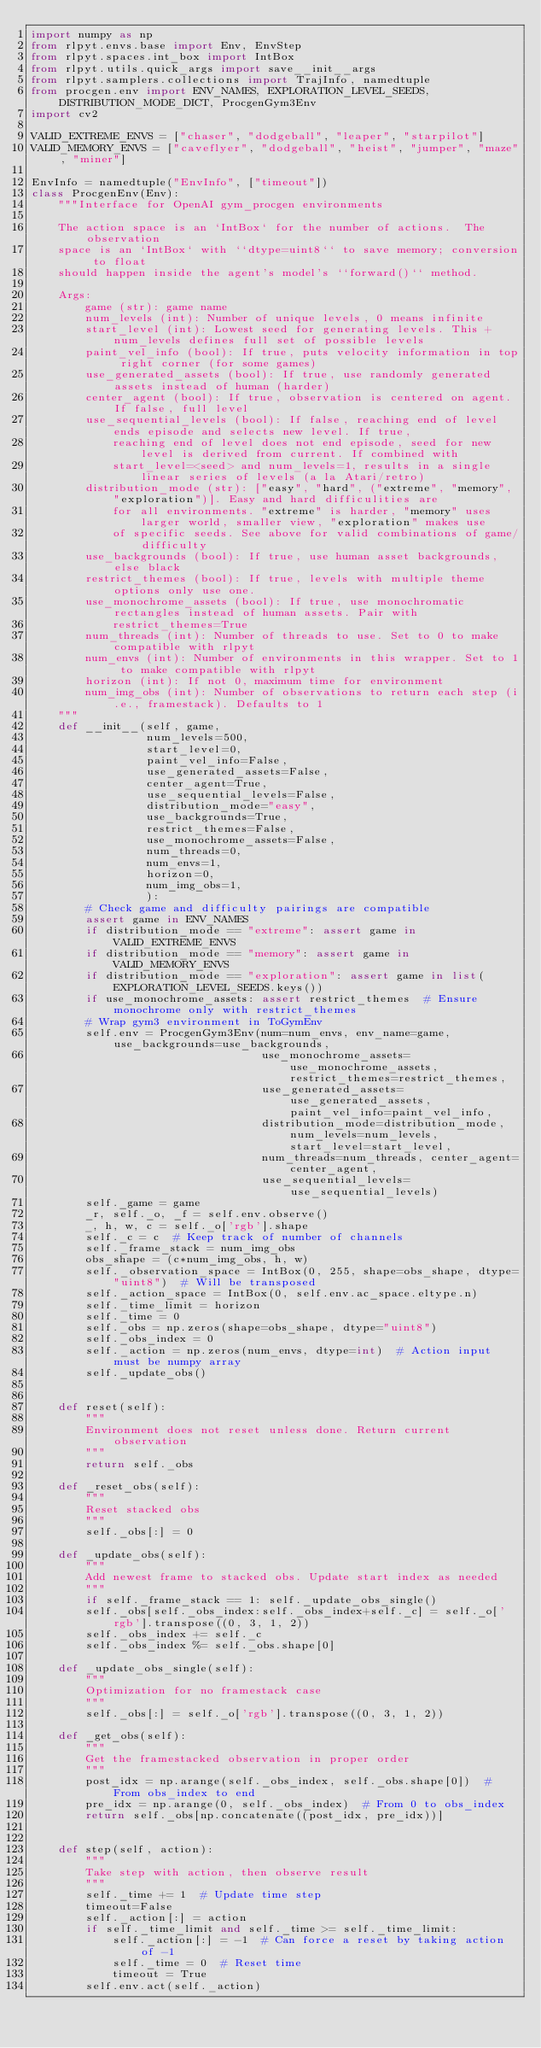<code> <loc_0><loc_0><loc_500><loc_500><_Python_>import numpy as np
from rlpyt.envs.base import Env, EnvStep
from rlpyt.spaces.int_box import IntBox
from rlpyt.utils.quick_args import save__init__args
from rlpyt.samplers.collections import TrajInfo, namedtuple
from procgen.env import ENV_NAMES, EXPLORATION_LEVEL_SEEDS, DISTRIBUTION_MODE_DICT, ProcgenGym3Env
import cv2

VALID_EXTREME_ENVS = ["chaser", "dodgeball", "leaper", "starpilot"]
VALID_MEMORY_ENVS = ["caveflyer", "dodgeball", "heist", "jumper", "maze", "miner"]

EnvInfo = namedtuple("EnvInfo", ["timeout"])
class ProcgenEnv(Env):
    """Interface for OpenAI gym_procgen environments

    The action space is an `IntBox` for the number of actions.  The observation
    space is an `IntBox` with ``dtype=uint8`` to save memory; conversion to float
    should happen inside the agent's model's ``forward()`` method.

    Args:
        game (str): game name
        num_levels (int): Number of unique levels, 0 means infinite
        start_level (int): Lowest seed for generating levels. This + num_levels defines full set of possible levels
        paint_vel_info (bool): If true, puts velocity information in top right corner (for some games)
        use_generated_assets (bool): If true, use randomly generated assets instead of human (harder)
        center_agent (bool): If true, observation is centered on agent. If false, full level
        use_sequential_levels (bool): If false, reaching end of level ends episode and selects new level. If true,
            reaching end of level does not end episode, seed for new level is derived from current. If combined with
            start_level=<seed> and num_levels=1, results in a single linear series of levels (a la Atari/retro)
        distribution_mode (str): ["easy", "hard", ("extreme", "memory", "exploration")]. Easy and hard difficulities are
            for all environments. "extreme" is harder, "memory" uses larger world, smaller view, "exploration" makes use
            of specific seeds. See above for valid combinations of game/difficulty
        use_backgrounds (bool): If true, use human asset backgrounds, else black
        restrict_themes (bool): If true, levels with multiple theme options only use one.
        use_monochrome_assets (bool): If true, use monochromatic rectangles instead of human assets. Pair with
            restrict_themes=True
        num_threads (int): Number of threads to use. Set to 0 to make compatible with rlpyt
        num_envs (int): Number of environments in this wrapper. Set to 1 to make compatible with rlpyt
        horizon (int): If not 0, maximum time for environment
        num_img_obs (int): Number of observations to return each step (i.e., framestack). Defaults to 1
    """
    def __init__(self, game,
                 num_levels=500,
                 start_level=0,
                 paint_vel_info=False,
                 use_generated_assets=False,
                 center_agent=True,
                 use_sequential_levels=False,
                 distribution_mode="easy",
                 use_backgrounds=True,
                 restrict_themes=False,
                 use_monochrome_assets=False,
                 num_threads=0,
                 num_envs=1,
                 horizon=0,
                 num_img_obs=1,
                 ):
        # Check game and difficulty pairings are compatible
        assert game in ENV_NAMES
        if distribution_mode == "extreme": assert game in VALID_EXTREME_ENVS
        if distribution_mode == "memory": assert game in VALID_MEMORY_ENVS
        if distribution_mode == "exploration": assert game in list(EXPLORATION_LEVEL_SEEDS.keys())
        if use_monochrome_assets: assert restrict_themes  # Ensure monochrome only with restrict_themes
        # Wrap gym3 environment in ToGymEnv
        self.env = ProcgenGym3Env(num=num_envs, env_name=game, use_backgrounds=use_backgrounds,
                                  use_monochrome_assets=use_monochrome_assets, restrict_themes=restrict_themes,
                                  use_generated_assets=use_generated_assets, paint_vel_info=paint_vel_info,
                                  distribution_mode=distribution_mode, num_levels=num_levels, start_level=start_level,
                                  num_threads=num_threads, center_agent=center_agent,
                                  use_sequential_levels=use_sequential_levels)
        self._game = game
        _r, self._o, _f = self.env.observe()
        _, h, w, c = self._o['rgb'].shape
        self._c = c  # Keep track of number of channels
        self._frame_stack = num_img_obs
        obs_shape = (c*num_img_obs, h, w)
        self._observation_space = IntBox(0, 255, shape=obs_shape, dtype="uint8")  # Will be transposed
        self._action_space = IntBox(0, self.env.ac_space.eltype.n)
        self._time_limit = horizon
        self._time = 0
        self._obs = np.zeros(shape=obs_shape, dtype="uint8")
        self._obs_index = 0
        self._action = np.zeros(num_envs, dtype=int)  # Action input must be numpy array
        self._update_obs()


    def reset(self):
        """
        Environment does not reset unless done. Return current observation
        """
        return self._obs

    def _reset_obs(self):
        """
        Reset stacked obs
        """
        self._obs[:] = 0

    def _update_obs(self):
        """
        Add newest frame to stacked obs. Update start index as needed
        """
        if self._frame_stack == 1: self._update_obs_single()
        self._obs[self._obs_index:self._obs_index+self._c] = self._o['rgb'].transpose((0, 3, 1, 2))
        self._obs_index += self._c
        self._obs_index %= self._obs.shape[0]

    def _update_obs_single(self):
        """
        Optimization for no framestack case
        """
        self._obs[:] = self._o['rgb'].transpose((0, 3, 1, 2))

    def _get_obs(self):
        """
        Get the framestacked observation in proper order
        """
        post_idx = np.arange(self._obs_index, self._obs.shape[0])  # From obs_index to end
        pre_idx = np.arange(0, self._obs_index)  # From 0 to obs_index
        return self._obs[np.concatenate((post_idx, pre_idx))]


    def step(self, action):
        """
        Take step with action, then observe result
        """
        self._time += 1  # Update time step
        timeout=False
        self._action[:] = action
        if self._time_limit and self._time >= self._time_limit:
            self._action[:] = -1  # Can force a reset by taking action of -1
            self._time = 0  # Reset time
            timeout = True
        self.env.act(self._action)</code> 